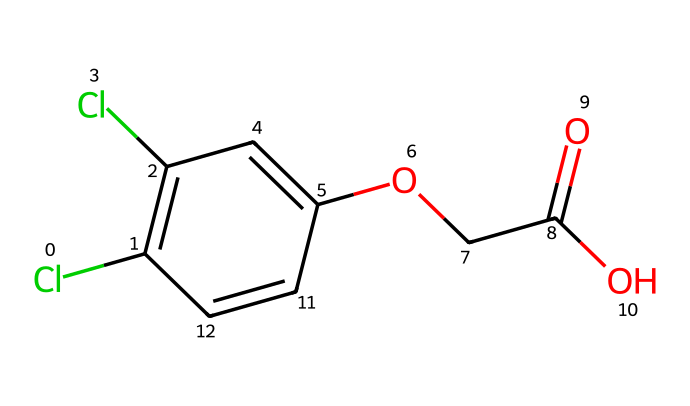How many chlorine atoms are present in this chemical? By examining the SMILES representation, there are two instances of 'Cl' which indicate chlorine atoms. Therefore, the count is simply 2.
Answer: 2 What is the functional group associated with the carboxylic acid in this chemical? Looking at the structure represented by the SMILES, we can identify the part 'C(=O)O' which clearly shows a carbonyl (C=O) and a hydroxyl group (–OH), characteristic of a carboxylic acid.
Answer: carboxylic acid What type of herbicide is 2,4-D classified as? Given that 2,4-D is a plant hormone mimic (specifically, an auxin), its classification as a herbicide is based on its mechanism of action which disrupts normal plant growth.
Answer: auxin How many aromatic rings are depicted in this chemical structure? The presence of 'C1=C' and similar notations suggests a cyclic structure, and counting the five-membered carbon rings yields one aromatic ring in the structure.
Answer: 1 What is the significance of the ether group in this herbicide? The ether group, indicated by 'OCC', plays a role in the herbicide's solubility and distribution within plant systems, affecting its overall efficacy against weeds.
Answer: solubility What carbon atom feature indicates this chemical's potential to form hydrogen bonds? The hydroxyl group ‘–OH’ in the structure can form hydrogen bonds due to the presence of an electronegative oxygen atom bonded to hydrogen, indicating this potential interaction.
Answer: hydroxyl group 